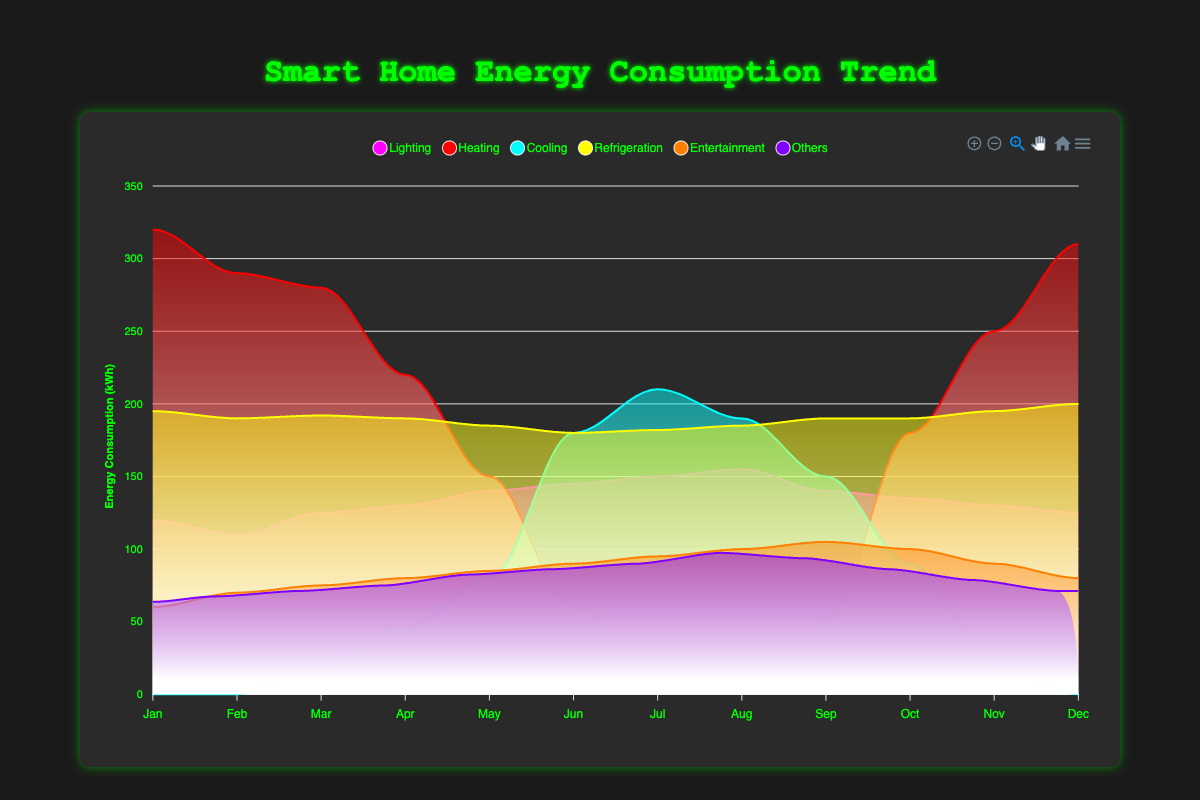What month had the highest energy consumption for Heating? From the chart, observe the area representing Heating. The highest peak appears in January.
Answer: January How did the Cooling energy consumption vary throughout the year? Examine the area representing Cooling which starts at zero in the winter months and peaks during the summer (June, July, and August), then decreases again towards the end of the year.
Answer: It increases in summer and decreases in winter Which appliance shows the least variation in energy consumption throughout the year? Compare the appliance areas. Refrigeration remains relatively steady compared to others.
Answer: Refrigeration What is the total energy consumption for all appliances in July? Sum the values for each appliance in July: 150 (Lighting) + 20 (Heating) + 210 (Cooling) + 182 (Refrigeration) + 95 (Entertainment) + 120 (Others) = 777 kWh.
Answer: 777 kWh Which month had the lowest total energy consumption? Sum the energy consumption for all appliances across all months and compare. February has the smallest sum.
Answer: February What is the general trend of Heating and Cooling energy consumption throughout the year? Heating starts high in winter and decreases towards summer. Cooling is zero in winter, increases and peaks in summer, then decreases.
Answer: Heating decreases while Cooling increases in summer Which appliance has the highest energy consumption in May? From the chart, observe the areas in May. Heating has the highest noticeable consumption.
Answer: Heating Compare the energy consumption of Lighting in January and July. From the chart, Lighting is 120 kWh in January and 150 kWh in July.
Answer: Higher in July How does the energy consumption of Entertainment change over the year? Entertainment consumption increases steadily throughout the year, peaking in September and reducing slightly towards the end of the year.
Answer: Increases, peaks in September, then slightly reduces What is the difference in energy consumption for Heating between January and June? The Heating consumption in January is 320 kWh and in June is 60 kWh. The difference is 320 - 60 = 260 kWh.
Answer: 260 kWh 